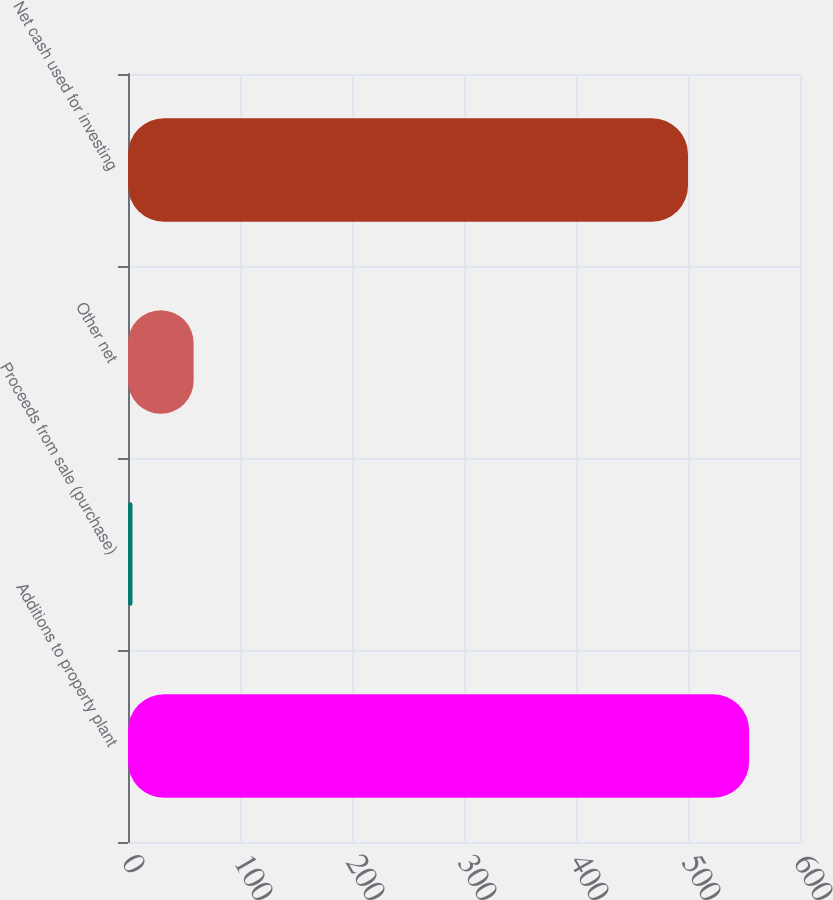Convert chart to OTSL. <chart><loc_0><loc_0><loc_500><loc_500><bar_chart><fcel>Additions to property plant<fcel>Proceeds from sale (purchase)<fcel>Other net<fcel>Net cash used for investing<nl><fcel>554.6<fcel>4<fcel>58.6<fcel>500<nl></chart> 